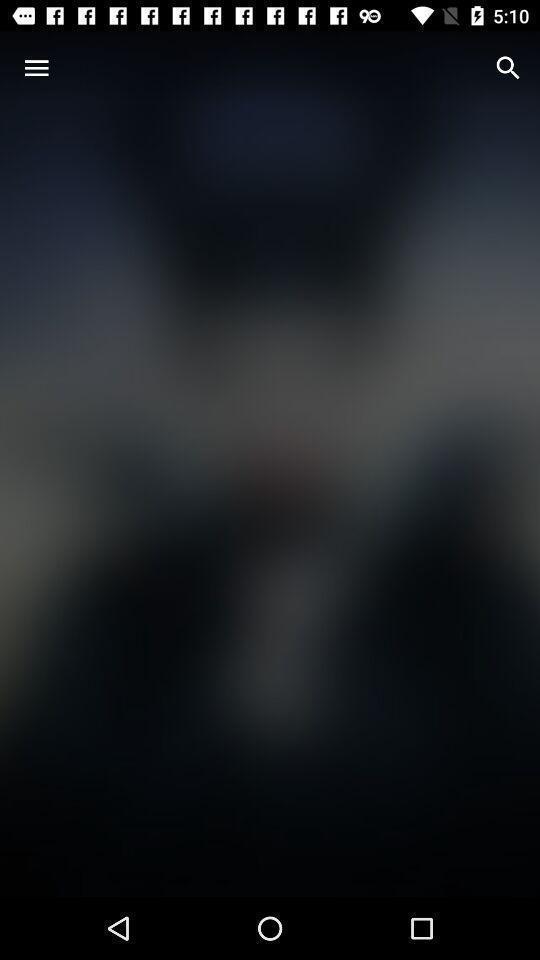Describe the key features of this screenshot. Page displaying search icon. 